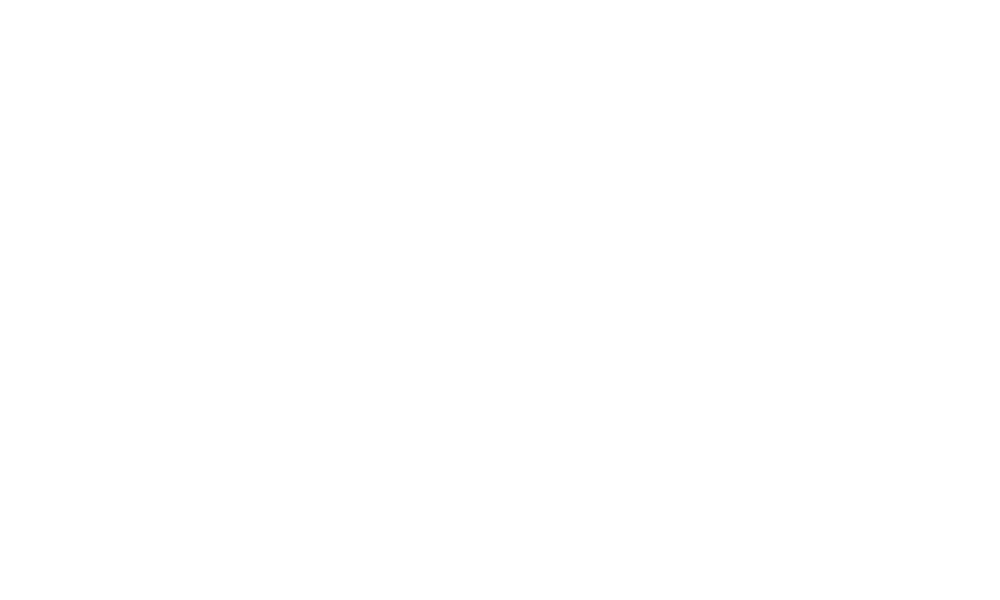Convert chart to OTSL. <chart><loc_0><loc_0><loc_500><loc_500><pie_chart><fcel>Net cash provided by/(used in)<nl><fcel>100.0%<nl></chart> 